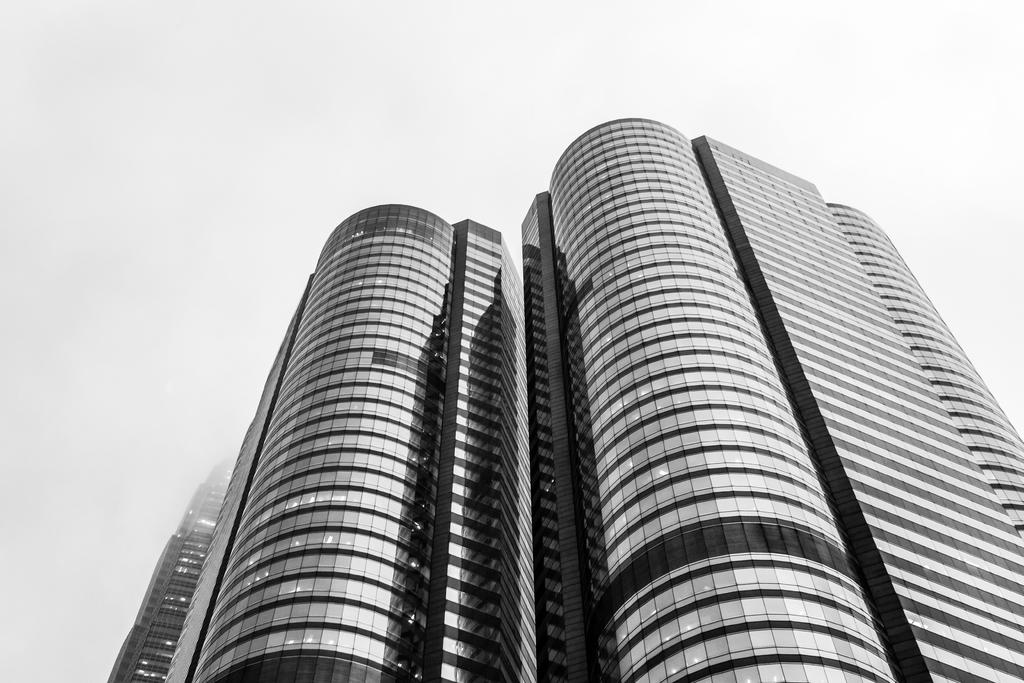What is the main subject of the picture? The main subject of the picture is a building. What specific feature can be observed on the building? The building has glass elements on it. What type of stem is growing from the building in the image? There is no stem growing from the building in the image. In which bedroom of the building can we see the glass elements? The image does not show any specific bedrooms, and the glass elements are visible on the exterior of the building. 